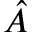<formula> <loc_0><loc_0><loc_500><loc_500>\hat { A }</formula> 